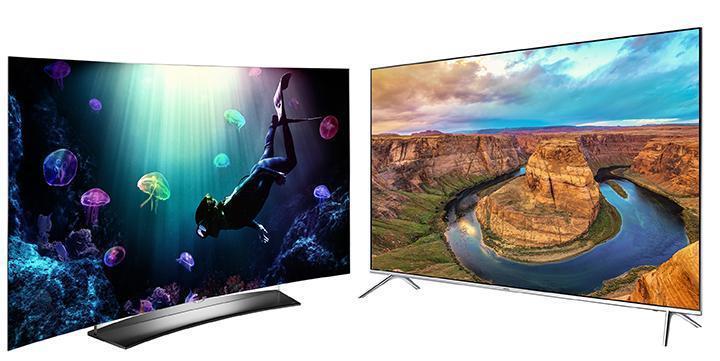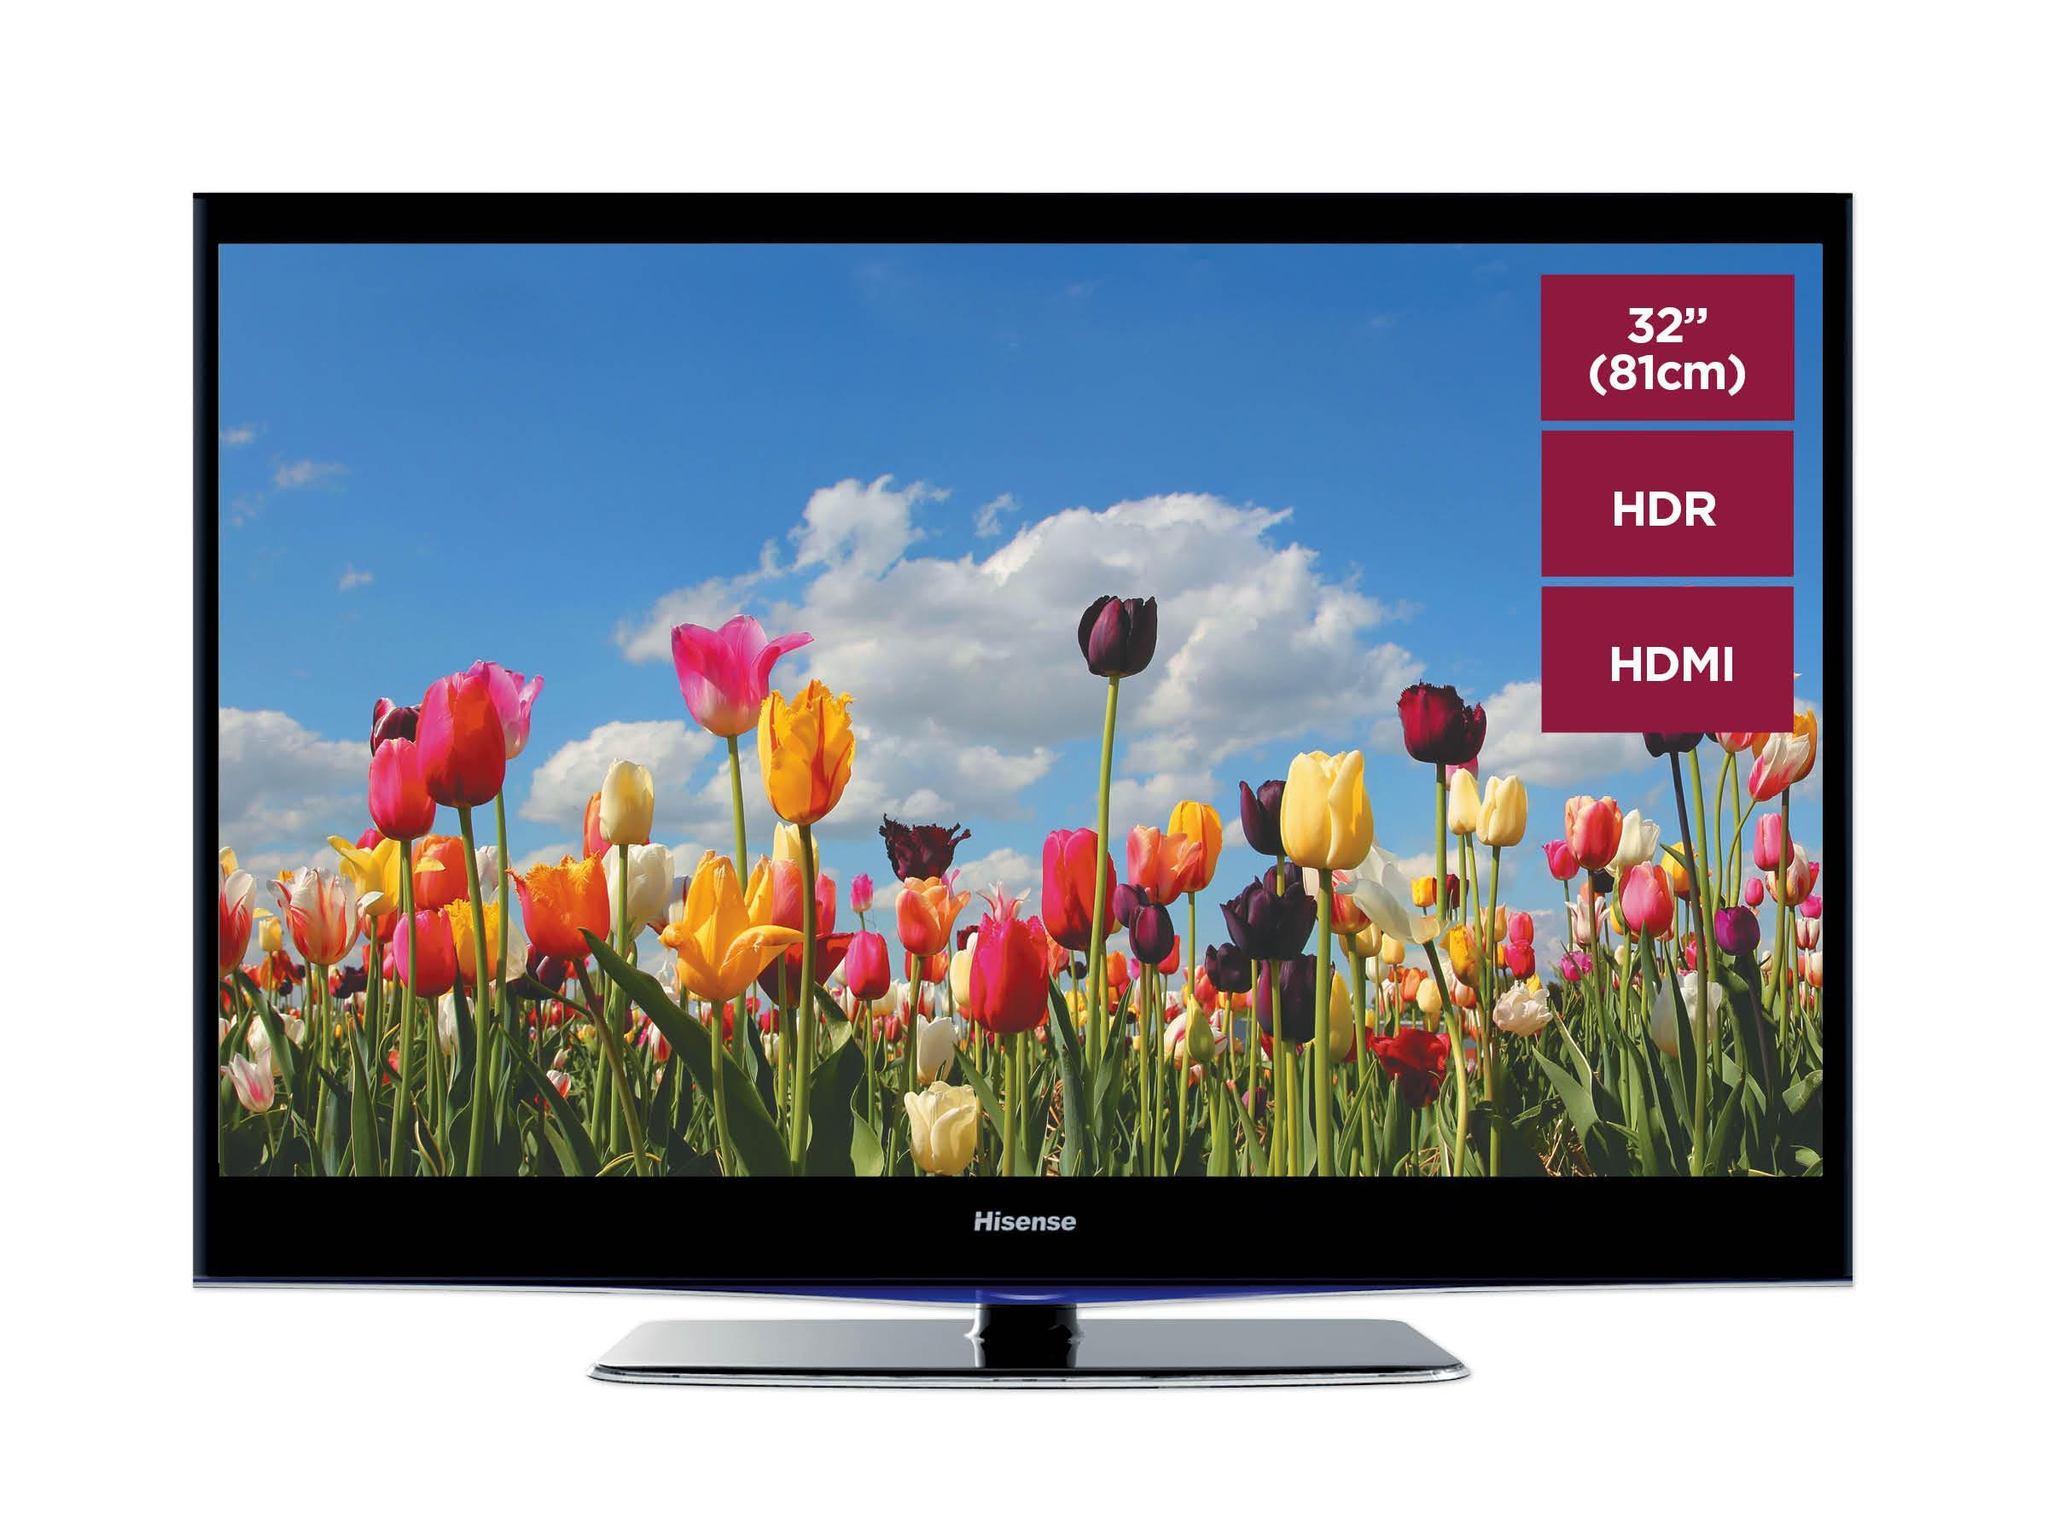The first image is the image on the left, the second image is the image on the right. Given the left and right images, does the statement "Each image shows a head-on view of one flat-screen TV on a short black stand, and each TV screen displays a watery blue scene." hold true? Answer yes or no. No. The first image is the image on the left, the second image is the image on the right. Considering the images on both sides, is "One television has a pair of end stands." valid? Answer yes or no. Yes. 